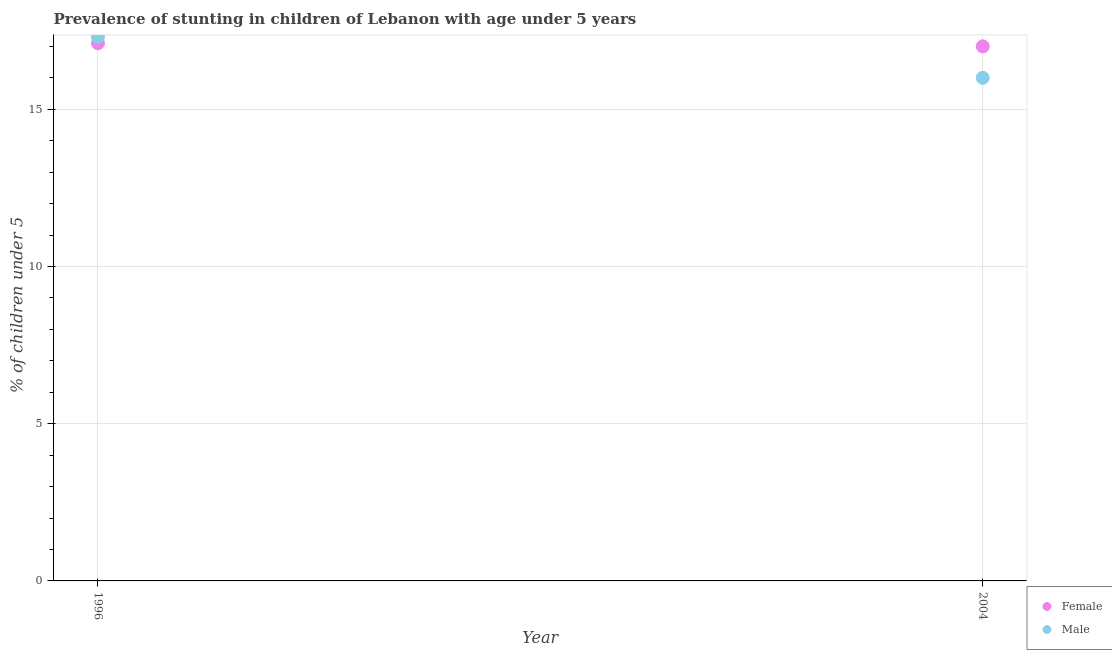Is the number of dotlines equal to the number of legend labels?
Your answer should be very brief. Yes. Across all years, what is the maximum percentage of stunted female children?
Keep it short and to the point. 17.1. In which year was the percentage of stunted male children maximum?
Keep it short and to the point. 1996. In which year was the percentage of stunted female children minimum?
Offer a terse response. 2004. What is the total percentage of stunted male children in the graph?
Keep it short and to the point. 33.3. What is the difference between the percentage of stunted female children in 1996 and that in 2004?
Offer a terse response. 0.1. What is the difference between the percentage of stunted female children in 1996 and the percentage of stunted male children in 2004?
Give a very brief answer. 1.1. What is the average percentage of stunted male children per year?
Offer a terse response. 16.65. In how many years, is the percentage of stunted female children greater than 15 %?
Ensure brevity in your answer.  2. What is the ratio of the percentage of stunted female children in 1996 to that in 2004?
Your answer should be compact. 1.01. Does the percentage of stunted male children monotonically increase over the years?
Provide a short and direct response. No. Is the percentage of stunted female children strictly greater than the percentage of stunted male children over the years?
Offer a very short reply. No. How many years are there in the graph?
Your response must be concise. 2. Does the graph contain any zero values?
Your answer should be compact. No. How many legend labels are there?
Your answer should be compact. 2. How are the legend labels stacked?
Your answer should be very brief. Vertical. What is the title of the graph?
Make the answer very short. Prevalence of stunting in children of Lebanon with age under 5 years. What is the label or title of the X-axis?
Provide a succinct answer. Year. What is the label or title of the Y-axis?
Provide a succinct answer.  % of children under 5. What is the  % of children under 5 in Female in 1996?
Keep it short and to the point. 17.1. What is the  % of children under 5 of Male in 1996?
Your answer should be compact. 17.3. What is the  % of children under 5 of Male in 2004?
Give a very brief answer. 16. Across all years, what is the maximum  % of children under 5 in Female?
Make the answer very short. 17.1. Across all years, what is the maximum  % of children under 5 of Male?
Give a very brief answer. 17.3. Across all years, what is the minimum  % of children under 5 in Male?
Make the answer very short. 16. What is the total  % of children under 5 of Female in the graph?
Provide a short and direct response. 34.1. What is the total  % of children under 5 of Male in the graph?
Give a very brief answer. 33.3. What is the difference between the  % of children under 5 in Female in 1996 and that in 2004?
Your answer should be compact. 0.1. What is the difference between the  % of children under 5 of Female in 1996 and the  % of children under 5 of Male in 2004?
Provide a short and direct response. 1.1. What is the average  % of children under 5 in Female per year?
Your answer should be compact. 17.05. What is the average  % of children under 5 of Male per year?
Offer a terse response. 16.65. In the year 1996, what is the difference between the  % of children under 5 of Female and  % of children under 5 of Male?
Your answer should be compact. -0.2. In the year 2004, what is the difference between the  % of children under 5 in Female and  % of children under 5 in Male?
Offer a very short reply. 1. What is the ratio of the  % of children under 5 in Female in 1996 to that in 2004?
Make the answer very short. 1.01. What is the ratio of the  % of children under 5 of Male in 1996 to that in 2004?
Offer a very short reply. 1.08. What is the difference between the highest and the second highest  % of children under 5 of Female?
Offer a very short reply. 0.1. What is the difference between the highest and the lowest  % of children under 5 in Male?
Give a very brief answer. 1.3. 